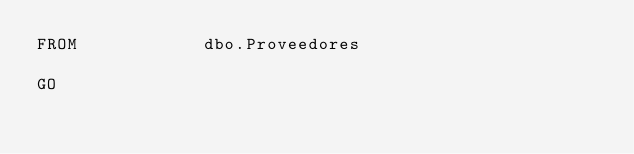<code> <loc_0><loc_0><loc_500><loc_500><_SQL_>FROM            dbo.Proveedores

GO</code> 